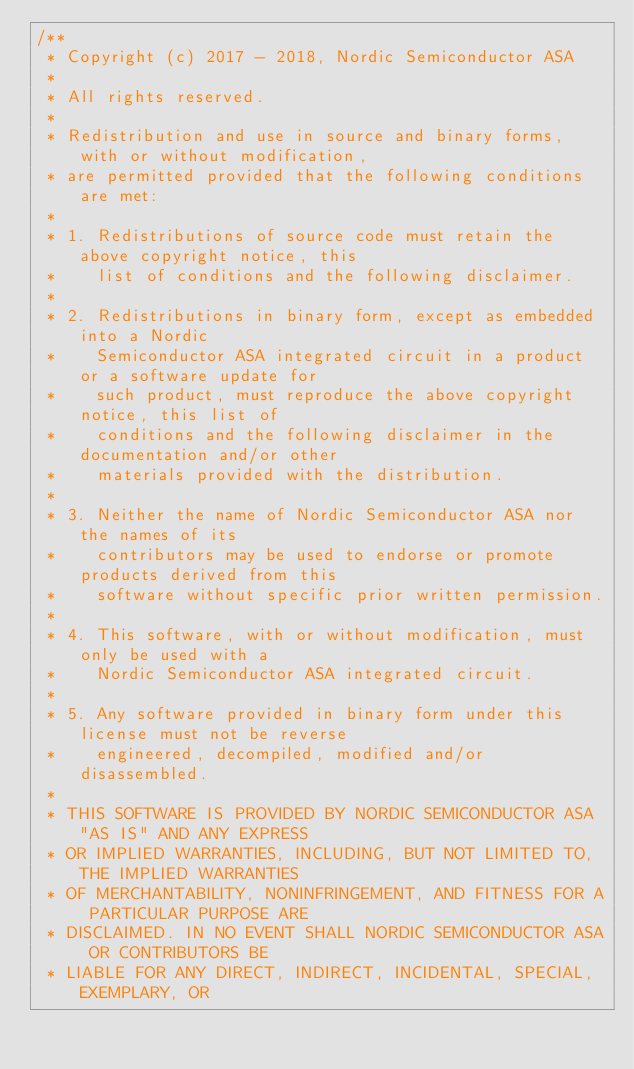<code> <loc_0><loc_0><loc_500><loc_500><_C_>/**
 * Copyright (c) 2017 - 2018, Nordic Semiconductor ASA
 * 
 * All rights reserved.
 * 
 * Redistribution and use in source and binary forms, with or without modification,
 * are permitted provided that the following conditions are met:
 * 
 * 1. Redistributions of source code must retain the above copyright notice, this
 *    list of conditions and the following disclaimer.
 * 
 * 2. Redistributions in binary form, except as embedded into a Nordic
 *    Semiconductor ASA integrated circuit in a product or a software update for
 *    such product, must reproduce the above copyright notice, this list of
 *    conditions and the following disclaimer in the documentation and/or other
 *    materials provided with the distribution.
 * 
 * 3. Neither the name of Nordic Semiconductor ASA nor the names of its
 *    contributors may be used to endorse or promote products derived from this
 *    software without specific prior written permission.
 * 
 * 4. This software, with or without modification, must only be used with a
 *    Nordic Semiconductor ASA integrated circuit.
 * 
 * 5. Any software provided in binary form under this license must not be reverse
 *    engineered, decompiled, modified and/or disassembled.
 * 
 * THIS SOFTWARE IS PROVIDED BY NORDIC SEMICONDUCTOR ASA "AS IS" AND ANY EXPRESS
 * OR IMPLIED WARRANTIES, INCLUDING, BUT NOT LIMITED TO, THE IMPLIED WARRANTIES
 * OF MERCHANTABILITY, NONINFRINGEMENT, AND FITNESS FOR A PARTICULAR PURPOSE ARE
 * DISCLAIMED. IN NO EVENT SHALL NORDIC SEMICONDUCTOR ASA OR CONTRIBUTORS BE
 * LIABLE FOR ANY DIRECT, INDIRECT, INCIDENTAL, SPECIAL, EXEMPLARY, OR</code> 